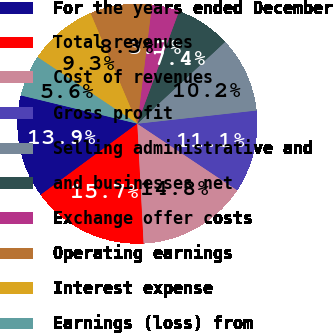<chart> <loc_0><loc_0><loc_500><loc_500><pie_chart><fcel>For the years ended December<fcel>Total revenues<fcel>Cost of revenues<fcel>Gross profit<fcel>Selling administrative and<fcel>and businesses net<fcel>Exchange offer costs<fcel>Operating earnings<fcel>Interest expense<fcel>Earnings (loss) from<nl><fcel>13.89%<fcel>15.74%<fcel>14.81%<fcel>11.11%<fcel>10.19%<fcel>7.41%<fcel>3.7%<fcel>8.33%<fcel>9.26%<fcel>5.56%<nl></chart> 